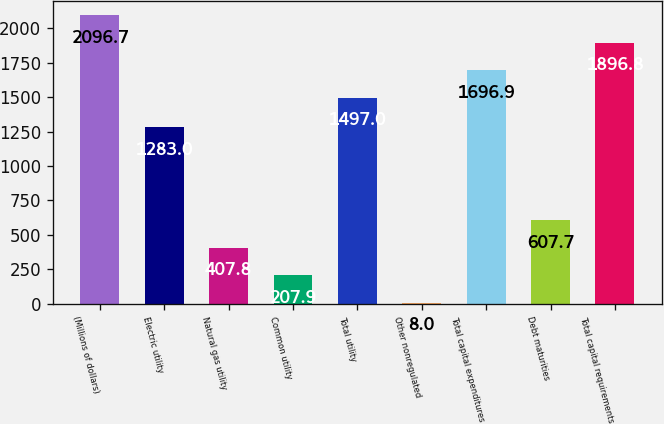Convert chart to OTSL. <chart><loc_0><loc_0><loc_500><loc_500><bar_chart><fcel>(Millions of dollars)<fcel>Electric utility<fcel>Natural gas utility<fcel>Common utility<fcel>Total utility<fcel>Other nonregulated<fcel>Total capital expenditures<fcel>Debt maturities<fcel>Total capital requirements<nl><fcel>2096.7<fcel>1283<fcel>407.8<fcel>207.9<fcel>1497<fcel>8<fcel>1696.9<fcel>607.7<fcel>1896.8<nl></chart> 